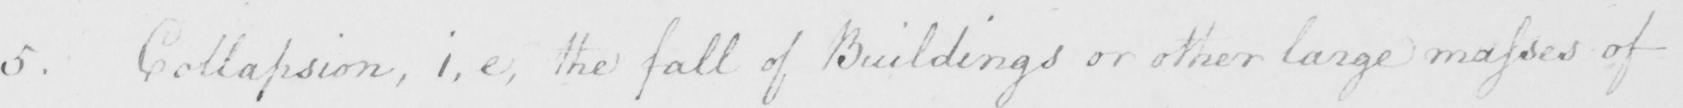What text is written in this handwritten line? 5 . Collapsion , i.e . the fall of Buildings or other large masses of 